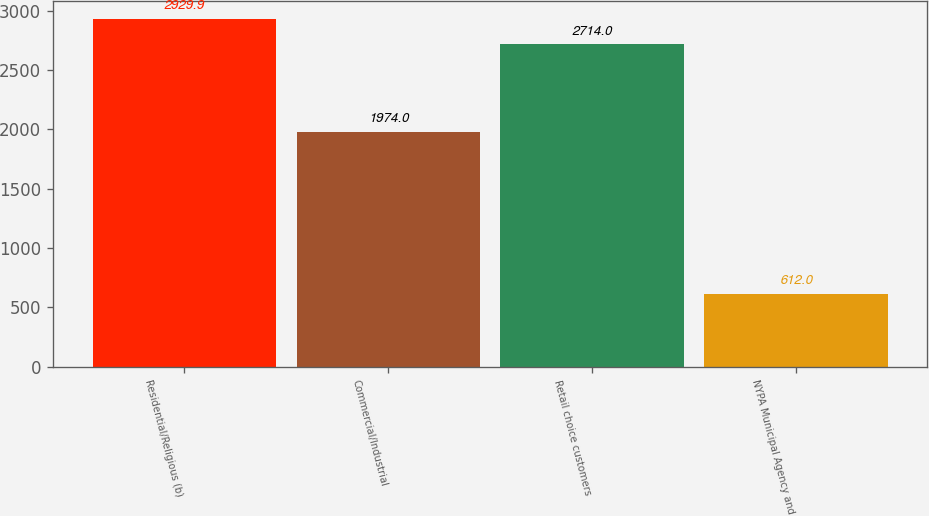Convert chart. <chart><loc_0><loc_0><loc_500><loc_500><bar_chart><fcel>Residential/Religious (b)<fcel>Commercial/Industrial<fcel>Retail choice customers<fcel>NYPA Municipal Agency and<nl><fcel>2929.9<fcel>1974<fcel>2714<fcel>612<nl></chart> 